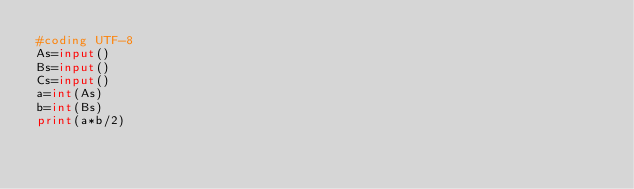Convert code to text. <code><loc_0><loc_0><loc_500><loc_500><_Python_>#coding UTF-8
As=input()
Bs=input()
Cs=input()
a=int(As)
b=int(Bs)
print(a*b/2)</code> 